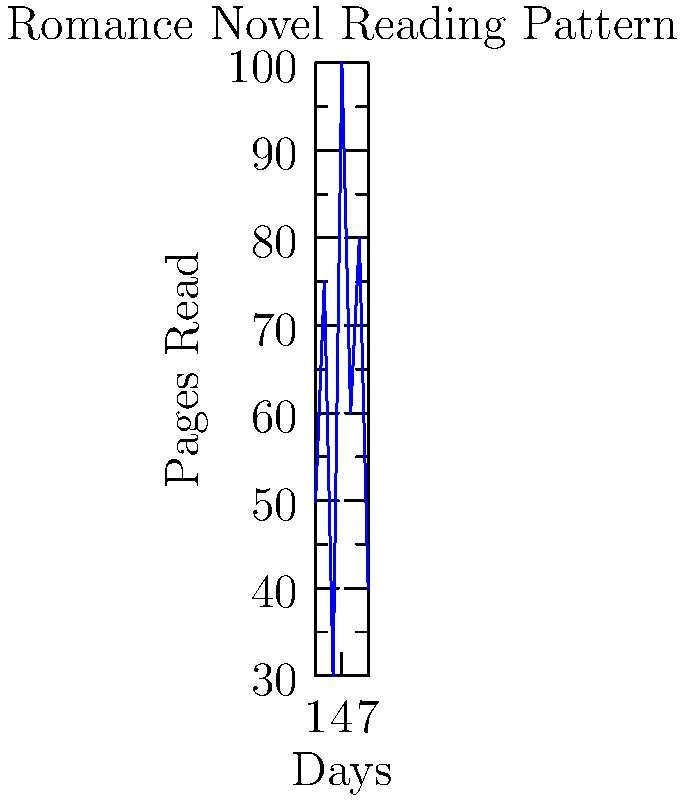As a busy mom who loves reading romance novels on her Kindle, you've tracked your daily reading progress for a week. The graph shows the number of pages read each day. If we represent this data as a vector in 7-dimensional space, what is the magnitude (length) of this vector, rounded to the nearest whole number? To solve this, let's follow these steps:

1. Identify the vector components:
   The vector is $(50, 75, 30, 100, 60, 80, 40)$, where each component represents pages read on a specific day.

2. Calculate the magnitude using the formula:
   For a vector $\mathbf{v} = (v_1, v_2, ..., v_n)$, the magnitude is given by:
   $$|\mathbf{v}| = \sqrt{v_1^2 + v_2^2 + ... + v_n^2}$$

3. Square each component:
   $50^2 + 75^2 + 30^2 + 100^2 + 60^2 + 80^2 + 40^2$

4. Add the squared values:
   $2500 + 5625 + 900 + 10000 + 3600 + 6400 + 1600 = 30625$

5. Take the square root:
   $$\sqrt{30625} \approx 175.0$$

6. Round to the nearest whole number:
   175
Answer: 175 pages 